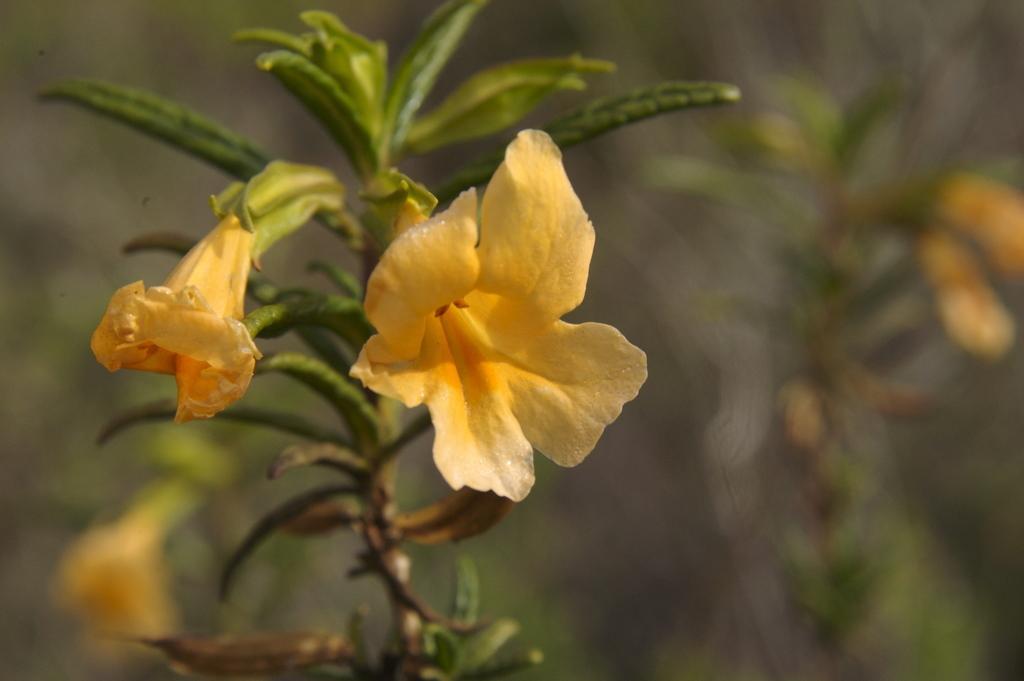Describe this image in one or two sentences. In this image we can see a plant with flowers. In the background the image is blur but we can see plants with flowers. 